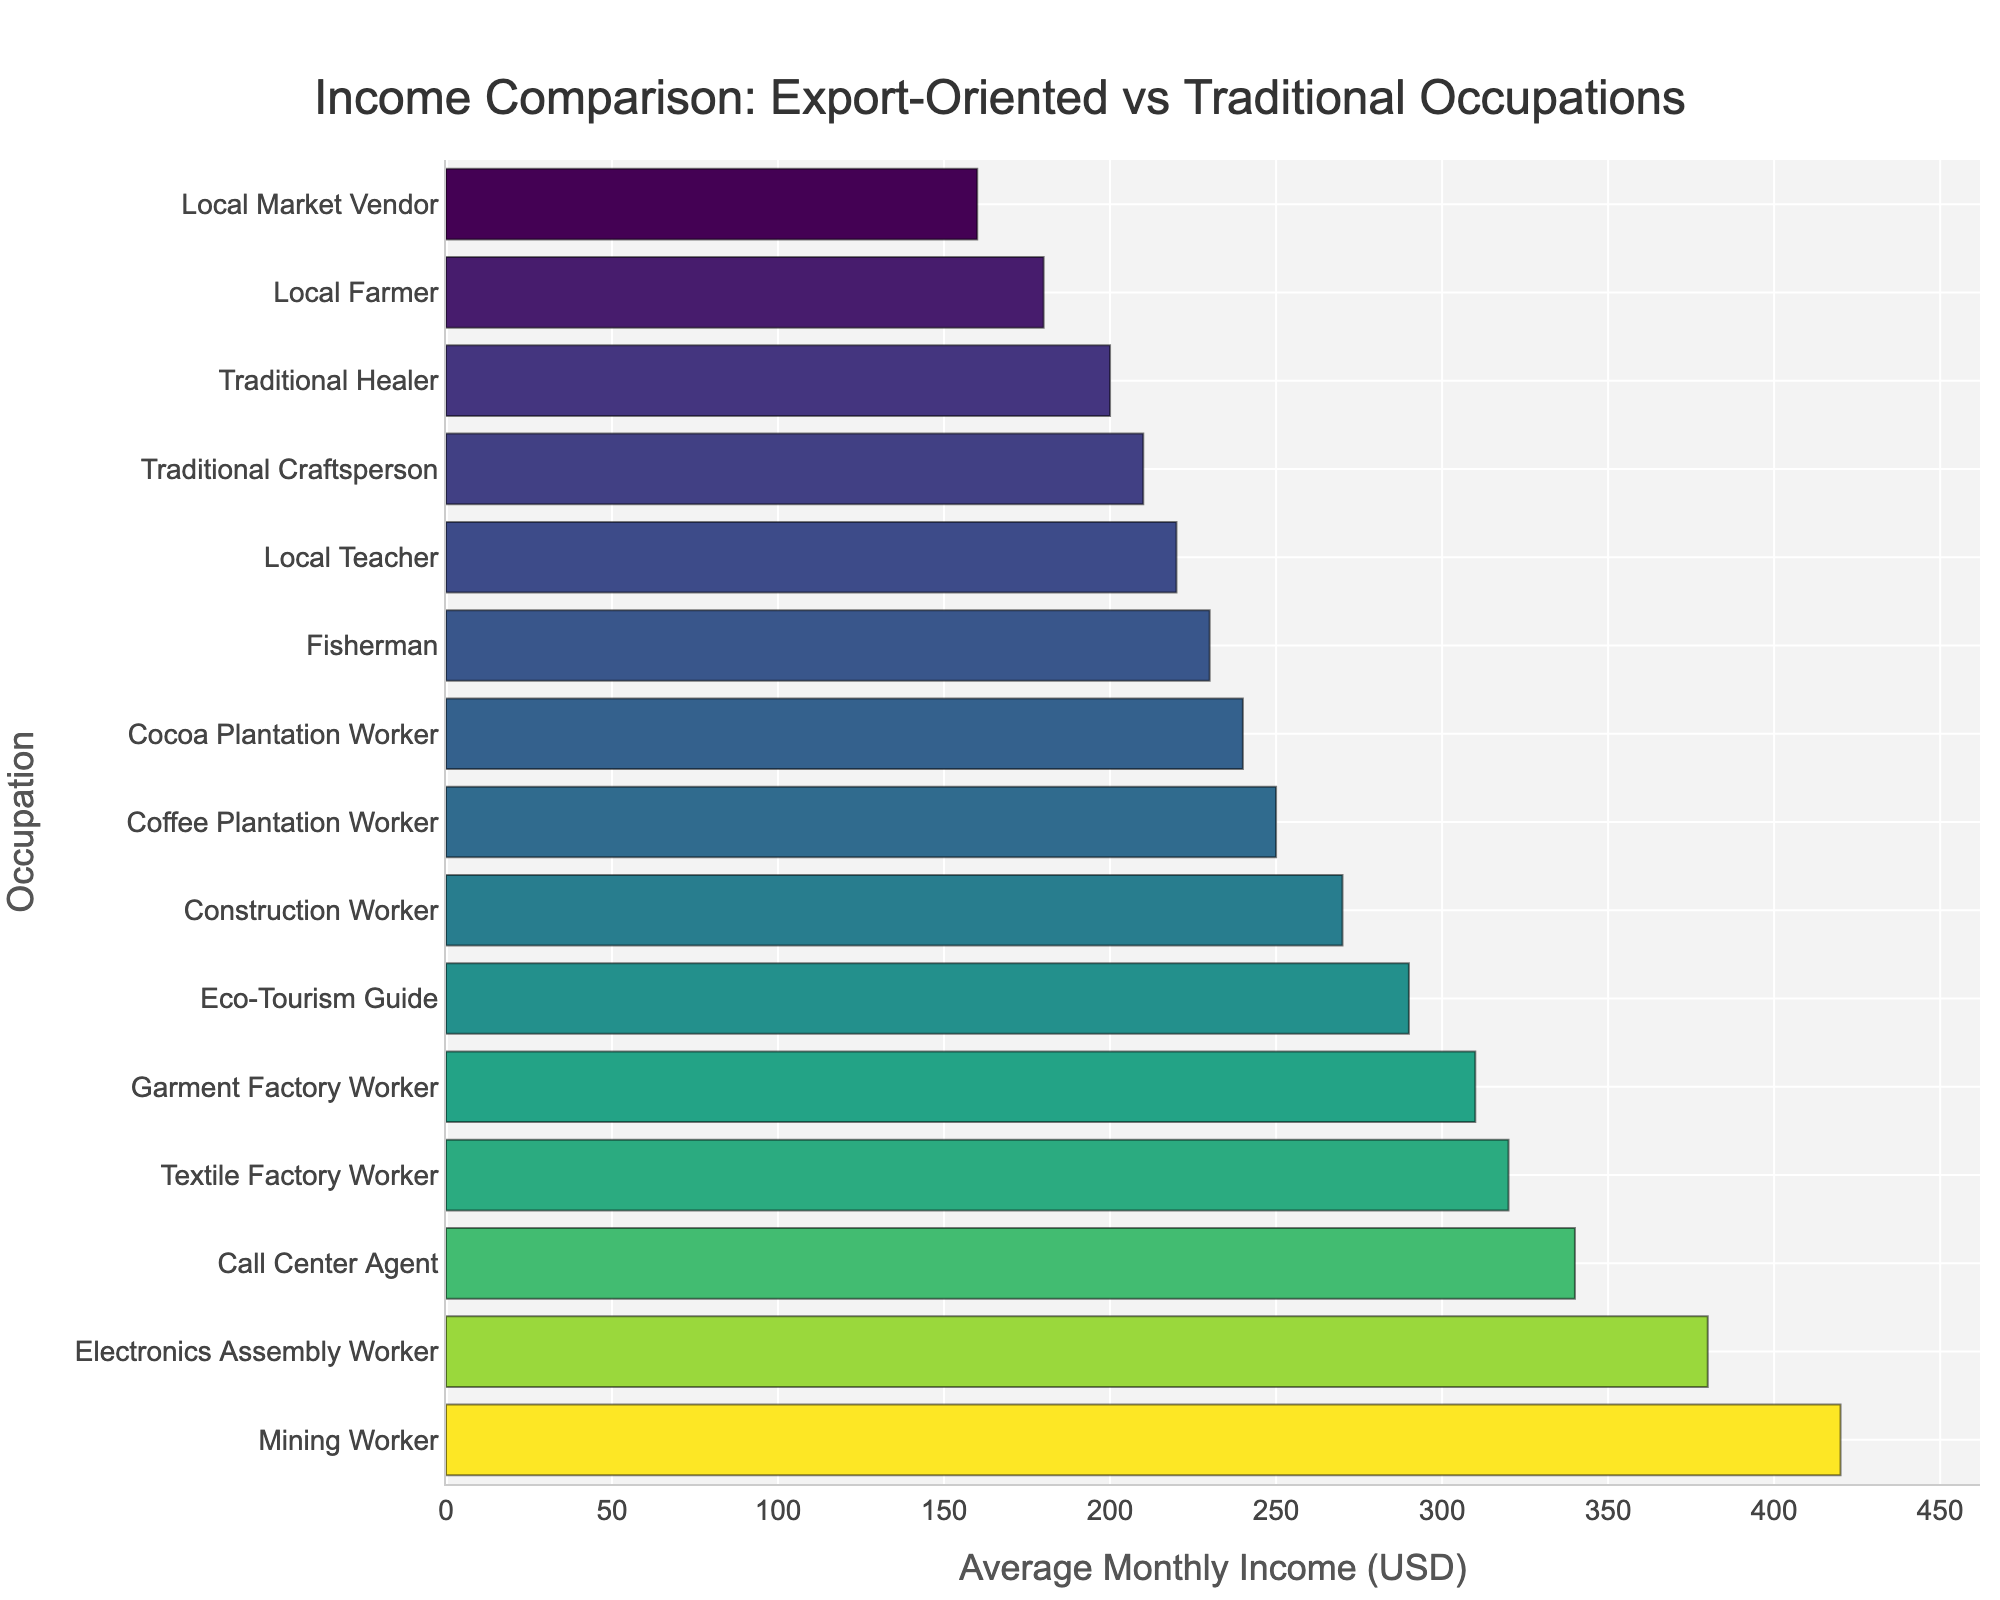Which occupation has the highest average monthly income? By looking at the bar that extends the farthest to the right, we can determine that the Mining Worker has the highest average monthly income.
Answer: Mining Worker Which occupation has the lowest average monthly income? By observing the bar that extends the shortest distance to the right, we find that the Local Market Vendor has the lowest average monthly income.
Answer: Local Market Vendor How much more does a Mining Worker earn compared to a Local Farmer? The average monthly income of a Mining Worker is $420, while a Local Farmer earns $180. The difference is $420 - $180.
Answer: $240 Which export-oriented occupation has the closest average monthly income to a Garment Factory Worker? The Garment Factory Worker earns $310 monthly. The closest export-oriented occupation is the Textile Factory Worker, who earns $320.
Answer: Textile Factory Worker What is the combined average monthly income of a Fisherman and a Traditional Healer? A Fisherman earns $230 monthly, and a Traditional Healer earns $200. The sum is $230 + $200.
Answer: $430 Which traditional occupation has a higher income than Textile Factory Worker? Scan the bars associated with traditional occupations and compare their lengths to that of the Textile Factory Worker ($320). The Eco-Tourism Guide earns $290, which is slightly lower. Therefore, no traditional occupation has a higher income.
Answer: None Compare the average monthly income of an Electronics Assembly Worker to a Call Center Agent. Which one earns more and by how much? The Electronics Assembly Worker earns $380, and the Call Center Agent earns $340. The difference is $380 - $340.
Answer: Electronics Assembly Worker, $40 Which occupation has an average monthly income exactly in the middle of the dataset? First, list the incomes: $160, $180, $200, $210, $220, $230, $240, $250, $270, $290, $310, $320, $340, $380, $420. With 15 data points, the median is the 8th value: $250 (Coffee Plantation Worker).
Answer: Coffee Plantation Worker What is the average monthly income difference between the highest and lowest traditional occupations? The highest traditional occupation (Eco-Tourism Guide) earns $290, and the lowest (Local Market Vendor) earns $160. The difference is $290 - $160.
Answer: $130 What is the average monthly income of all export-oriented occupations combined? Summing the incomes: $320 (Textile Factory Worker) + $380 (Electronics Assembly Worker) + $340 (Call Center Agent) + $420 (Mining Worker) + $310 (Garment Factory Worker) = $1770. There are 5 occupations, so the average is $1770 / 5.
Answer: $354 